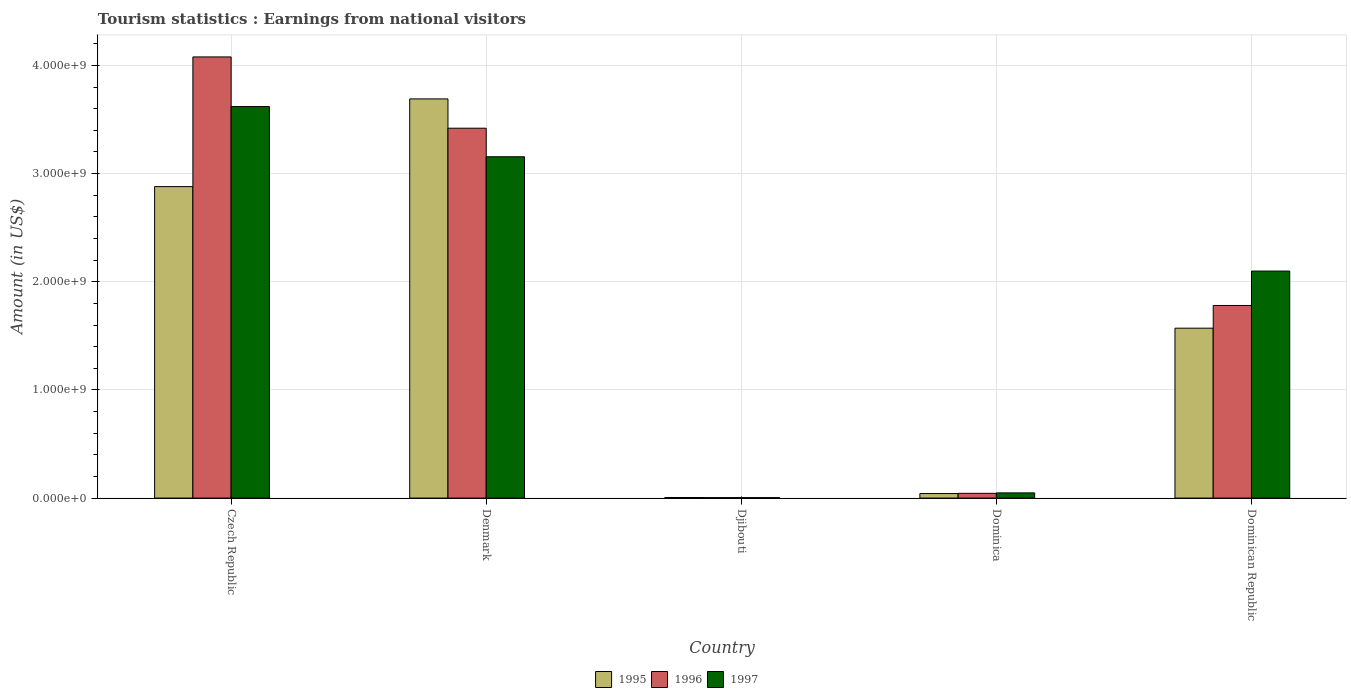How many different coloured bars are there?
Your response must be concise. 3. How many groups of bars are there?
Offer a terse response. 5. Are the number of bars on each tick of the X-axis equal?
Offer a very short reply. Yes. What is the label of the 4th group of bars from the left?
Your answer should be compact. Dominica. In how many cases, is the number of bars for a given country not equal to the number of legend labels?
Provide a succinct answer. 0. What is the earnings from national visitors in 1995 in Czech Republic?
Offer a very short reply. 2.88e+09. Across all countries, what is the maximum earnings from national visitors in 1997?
Offer a very short reply. 3.62e+09. Across all countries, what is the minimum earnings from national visitors in 1995?
Keep it short and to the point. 5.40e+06. In which country was the earnings from national visitors in 1995 maximum?
Provide a succinct answer. Denmark. In which country was the earnings from national visitors in 1996 minimum?
Your response must be concise. Djibouti. What is the total earnings from national visitors in 1997 in the graph?
Make the answer very short. 8.93e+09. What is the difference between the earnings from national visitors in 1997 in Denmark and that in Djibouti?
Offer a very short reply. 3.15e+09. What is the difference between the earnings from national visitors in 1996 in Dominican Republic and the earnings from national visitors in 1997 in Djibouti?
Your answer should be compact. 1.78e+09. What is the average earnings from national visitors in 1995 per country?
Provide a succinct answer. 1.64e+09. What is the difference between the earnings from national visitors of/in 1997 and earnings from national visitors of/in 1996 in Djibouti?
Make the answer very short. -4.00e+05. In how many countries, is the earnings from national visitors in 1995 greater than 400000000 US$?
Provide a short and direct response. 3. What is the ratio of the earnings from national visitors in 1997 in Djibouti to that in Dominica?
Provide a succinct answer. 0.09. What is the difference between the highest and the second highest earnings from national visitors in 1995?
Keep it short and to the point. 8.11e+08. What is the difference between the highest and the lowest earnings from national visitors in 1996?
Your answer should be compact. 4.07e+09. In how many countries, is the earnings from national visitors in 1996 greater than the average earnings from national visitors in 1996 taken over all countries?
Your answer should be compact. 2. What does the 1st bar from the left in Dominican Republic represents?
Give a very brief answer. 1995. What does the 1st bar from the right in Czech Republic represents?
Provide a short and direct response. 1997. How many countries are there in the graph?
Your answer should be compact. 5. What is the difference between two consecutive major ticks on the Y-axis?
Provide a succinct answer. 1.00e+09. Does the graph contain any zero values?
Offer a terse response. No. Does the graph contain grids?
Offer a terse response. Yes. Where does the legend appear in the graph?
Offer a terse response. Bottom center. How many legend labels are there?
Offer a very short reply. 3. What is the title of the graph?
Provide a short and direct response. Tourism statistics : Earnings from national visitors. Does "1965" appear as one of the legend labels in the graph?
Your answer should be compact. No. What is the Amount (in US$) of 1995 in Czech Republic?
Make the answer very short. 2.88e+09. What is the Amount (in US$) of 1996 in Czech Republic?
Your answer should be very brief. 4.08e+09. What is the Amount (in US$) of 1997 in Czech Republic?
Give a very brief answer. 3.62e+09. What is the Amount (in US$) in 1995 in Denmark?
Provide a succinct answer. 3.69e+09. What is the Amount (in US$) of 1996 in Denmark?
Offer a very short reply. 3.42e+09. What is the Amount (in US$) of 1997 in Denmark?
Your answer should be compact. 3.16e+09. What is the Amount (in US$) in 1995 in Djibouti?
Provide a succinct answer. 5.40e+06. What is the Amount (in US$) in 1996 in Djibouti?
Your answer should be compact. 4.60e+06. What is the Amount (in US$) in 1997 in Djibouti?
Offer a terse response. 4.20e+06. What is the Amount (in US$) in 1995 in Dominica?
Make the answer very short. 4.20e+07. What is the Amount (in US$) of 1996 in Dominica?
Your answer should be very brief. 4.40e+07. What is the Amount (in US$) of 1997 in Dominica?
Give a very brief answer. 4.80e+07. What is the Amount (in US$) of 1995 in Dominican Republic?
Ensure brevity in your answer.  1.57e+09. What is the Amount (in US$) of 1996 in Dominican Republic?
Ensure brevity in your answer.  1.78e+09. What is the Amount (in US$) in 1997 in Dominican Republic?
Provide a succinct answer. 2.10e+09. Across all countries, what is the maximum Amount (in US$) in 1995?
Your answer should be compact. 3.69e+09. Across all countries, what is the maximum Amount (in US$) of 1996?
Offer a very short reply. 4.08e+09. Across all countries, what is the maximum Amount (in US$) of 1997?
Make the answer very short. 3.62e+09. Across all countries, what is the minimum Amount (in US$) of 1995?
Your answer should be compact. 5.40e+06. Across all countries, what is the minimum Amount (in US$) of 1996?
Your answer should be compact. 4.60e+06. Across all countries, what is the minimum Amount (in US$) of 1997?
Your answer should be compact. 4.20e+06. What is the total Amount (in US$) in 1995 in the graph?
Provide a short and direct response. 8.19e+09. What is the total Amount (in US$) of 1996 in the graph?
Offer a very short reply. 9.33e+09. What is the total Amount (in US$) in 1997 in the graph?
Make the answer very short. 8.93e+09. What is the difference between the Amount (in US$) in 1995 in Czech Republic and that in Denmark?
Give a very brief answer. -8.11e+08. What is the difference between the Amount (in US$) in 1996 in Czech Republic and that in Denmark?
Offer a very short reply. 6.59e+08. What is the difference between the Amount (in US$) in 1997 in Czech Republic and that in Denmark?
Offer a terse response. 4.64e+08. What is the difference between the Amount (in US$) in 1995 in Czech Republic and that in Djibouti?
Make the answer very short. 2.87e+09. What is the difference between the Amount (in US$) in 1996 in Czech Republic and that in Djibouti?
Your response must be concise. 4.07e+09. What is the difference between the Amount (in US$) of 1997 in Czech Republic and that in Djibouti?
Your answer should be compact. 3.62e+09. What is the difference between the Amount (in US$) in 1995 in Czech Republic and that in Dominica?
Your response must be concise. 2.84e+09. What is the difference between the Amount (in US$) in 1996 in Czech Republic and that in Dominica?
Ensure brevity in your answer.  4.04e+09. What is the difference between the Amount (in US$) of 1997 in Czech Republic and that in Dominica?
Your response must be concise. 3.57e+09. What is the difference between the Amount (in US$) in 1995 in Czech Republic and that in Dominican Republic?
Your response must be concise. 1.31e+09. What is the difference between the Amount (in US$) in 1996 in Czech Republic and that in Dominican Republic?
Make the answer very short. 2.30e+09. What is the difference between the Amount (in US$) in 1997 in Czech Republic and that in Dominican Republic?
Your answer should be compact. 1.52e+09. What is the difference between the Amount (in US$) of 1995 in Denmark and that in Djibouti?
Offer a very short reply. 3.69e+09. What is the difference between the Amount (in US$) of 1996 in Denmark and that in Djibouti?
Your answer should be very brief. 3.42e+09. What is the difference between the Amount (in US$) in 1997 in Denmark and that in Djibouti?
Ensure brevity in your answer.  3.15e+09. What is the difference between the Amount (in US$) of 1995 in Denmark and that in Dominica?
Ensure brevity in your answer.  3.65e+09. What is the difference between the Amount (in US$) of 1996 in Denmark and that in Dominica?
Offer a terse response. 3.38e+09. What is the difference between the Amount (in US$) in 1997 in Denmark and that in Dominica?
Provide a short and direct response. 3.11e+09. What is the difference between the Amount (in US$) in 1995 in Denmark and that in Dominican Republic?
Offer a terse response. 2.12e+09. What is the difference between the Amount (in US$) in 1996 in Denmark and that in Dominican Republic?
Provide a succinct answer. 1.64e+09. What is the difference between the Amount (in US$) of 1997 in Denmark and that in Dominican Republic?
Make the answer very short. 1.06e+09. What is the difference between the Amount (in US$) in 1995 in Djibouti and that in Dominica?
Provide a short and direct response. -3.66e+07. What is the difference between the Amount (in US$) in 1996 in Djibouti and that in Dominica?
Provide a short and direct response. -3.94e+07. What is the difference between the Amount (in US$) in 1997 in Djibouti and that in Dominica?
Make the answer very short. -4.38e+07. What is the difference between the Amount (in US$) of 1995 in Djibouti and that in Dominican Republic?
Offer a terse response. -1.57e+09. What is the difference between the Amount (in US$) in 1996 in Djibouti and that in Dominican Republic?
Ensure brevity in your answer.  -1.78e+09. What is the difference between the Amount (in US$) of 1997 in Djibouti and that in Dominican Republic?
Offer a very short reply. -2.09e+09. What is the difference between the Amount (in US$) in 1995 in Dominica and that in Dominican Republic?
Offer a very short reply. -1.53e+09. What is the difference between the Amount (in US$) in 1996 in Dominica and that in Dominican Republic?
Give a very brief answer. -1.74e+09. What is the difference between the Amount (in US$) of 1997 in Dominica and that in Dominican Republic?
Provide a short and direct response. -2.05e+09. What is the difference between the Amount (in US$) of 1995 in Czech Republic and the Amount (in US$) of 1996 in Denmark?
Ensure brevity in your answer.  -5.40e+08. What is the difference between the Amount (in US$) of 1995 in Czech Republic and the Amount (in US$) of 1997 in Denmark?
Ensure brevity in your answer.  -2.76e+08. What is the difference between the Amount (in US$) of 1996 in Czech Republic and the Amount (in US$) of 1997 in Denmark?
Offer a very short reply. 9.23e+08. What is the difference between the Amount (in US$) in 1995 in Czech Republic and the Amount (in US$) in 1996 in Djibouti?
Your answer should be very brief. 2.88e+09. What is the difference between the Amount (in US$) in 1995 in Czech Republic and the Amount (in US$) in 1997 in Djibouti?
Make the answer very short. 2.88e+09. What is the difference between the Amount (in US$) of 1996 in Czech Republic and the Amount (in US$) of 1997 in Djibouti?
Make the answer very short. 4.07e+09. What is the difference between the Amount (in US$) in 1995 in Czech Republic and the Amount (in US$) in 1996 in Dominica?
Provide a succinct answer. 2.84e+09. What is the difference between the Amount (in US$) of 1995 in Czech Republic and the Amount (in US$) of 1997 in Dominica?
Ensure brevity in your answer.  2.83e+09. What is the difference between the Amount (in US$) in 1996 in Czech Republic and the Amount (in US$) in 1997 in Dominica?
Give a very brief answer. 4.03e+09. What is the difference between the Amount (in US$) of 1995 in Czech Republic and the Amount (in US$) of 1996 in Dominican Republic?
Ensure brevity in your answer.  1.10e+09. What is the difference between the Amount (in US$) in 1995 in Czech Republic and the Amount (in US$) in 1997 in Dominican Republic?
Ensure brevity in your answer.  7.81e+08. What is the difference between the Amount (in US$) in 1996 in Czech Republic and the Amount (in US$) in 1997 in Dominican Republic?
Offer a terse response. 1.98e+09. What is the difference between the Amount (in US$) in 1995 in Denmark and the Amount (in US$) in 1996 in Djibouti?
Offer a terse response. 3.69e+09. What is the difference between the Amount (in US$) in 1995 in Denmark and the Amount (in US$) in 1997 in Djibouti?
Offer a terse response. 3.69e+09. What is the difference between the Amount (in US$) of 1996 in Denmark and the Amount (in US$) of 1997 in Djibouti?
Your answer should be very brief. 3.42e+09. What is the difference between the Amount (in US$) of 1995 in Denmark and the Amount (in US$) of 1996 in Dominica?
Provide a succinct answer. 3.65e+09. What is the difference between the Amount (in US$) of 1995 in Denmark and the Amount (in US$) of 1997 in Dominica?
Keep it short and to the point. 3.64e+09. What is the difference between the Amount (in US$) in 1996 in Denmark and the Amount (in US$) in 1997 in Dominica?
Ensure brevity in your answer.  3.37e+09. What is the difference between the Amount (in US$) of 1995 in Denmark and the Amount (in US$) of 1996 in Dominican Republic?
Offer a very short reply. 1.91e+09. What is the difference between the Amount (in US$) of 1995 in Denmark and the Amount (in US$) of 1997 in Dominican Republic?
Give a very brief answer. 1.59e+09. What is the difference between the Amount (in US$) of 1996 in Denmark and the Amount (in US$) of 1997 in Dominican Republic?
Your answer should be very brief. 1.32e+09. What is the difference between the Amount (in US$) of 1995 in Djibouti and the Amount (in US$) of 1996 in Dominica?
Give a very brief answer. -3.86e+07. What is the difference between the Amount (in US$) of 1995 in Djibouti and the Amount (in US$) of 1997 in Dominica?
Give a very brief answer. -4.26e+07. What is the difference between the Amount (in US$) in 1996 in Djibouti and the Amount (in US$) in 1997 in Dominica?
Make the answer very short. -4.34e+07. What is the difference between the Amount (in US$) of 1995 in Djibouti and the Amount (in US$) of 1996 in Dominican Republic?
Provide a short and direct response. -1.78e+09. What is the difference between the Amount (in US$) in 1995 in Djibouti and the Amount (in US$) in 1997 in Dominican Republic?
Keep it short and to the point. -2.09e+09. What is the difference between the Amount (in US$) of 1996 in Djibouti and the Amount (in US$) of 1997 in Dominican Republic?
Keep it short and to the point. -2.09e+09. What is the difference between the Amount (in US$) in 1995 in Dominica and the Amount (in US$) in 1996 in Dominican Republic?
Give a very brief answer. -1.74e+09. What is the difference between the Amount (in US$) of 1995 in Dominica and the Amount (in US$) of 1997 in Dominican Republic?
Ensure brevity in your answer.  -2.06e+09. What is the difference between the Amount (in US$) of 1996 in Dominica and the Amount (in US$) of 1997 in Dominican Republic?
Make the answer very short. -2.06e+09. What is the average Amount (in US$) of 1995 per country?
Your response must be concise. 1.64e+09. What is the average Amount (in US$) of 1996 per country?
Your answer should be very brief. 1.87e+09. What is the average Amount (in US$) in 1997 per country?
Keep it short and to the point. 1.79e+09. What is the difference between the Amount (in US$) of 1995 and Amount (in US$) of 1996 in Czech Republic?
Your answer should be very brief. -1.20e+09. What is the difference between the Amount (in US$) of 1995 and Amount (in US$) of 1997 in Czech Republic?
Provide a short and direct response. -7.40e+08. What is the difference between the Amount (in US$) of 1996 and Amount (in US$) of 1997 in Czech Republic?
Provide a short and direct response. 4.59e+08. What is the difference between the Amount (in US$) of 1995 and Amount (in US$) of 1996 in Denmark?
Provide a short and direct response. 2.71e+08. What is the difference between the Amount (in US$) of 1995 and Amount (in US$) of 1997 in Denmark?
Your response must be concise. 5.35e+08. What is the difference between the Amount (in US$) in 1996 and Amount (in US$) in 1997 in Denmark?
Give a very brief answer. 2.64e+08. What is the difference between the Amount (in US$) of 1995 and Amount (in US$) of 1996 in Djibouti?
Offer a very short reply. 8.00e+05. What is the difference between the Amount (in US$) in 1995 and Amount (in US$) in 1997 in Djibouti?
Offer a terse response. 1.20e+06. What is the difference between the Amount (in US$) of 1996 and Amount (in US$) of 1997 in Djibouti?
Keep it short and to the point. 4.00e+05. What is the difference between the Amount (in US$) of 1995 and Amount (in US$) of 1996 in Dominica?
Offer a very short reply. -2.00e+06. What is the difference between the Amount (in US$) in 1995 and Amount (in US$) in 1997 in Dominica?
Provide a succinct answer. -6.00e+06. What is the difference between the Amount (in US$) of 1996 and Amount (in US$) of 1997 in Dominica?
Ensure brevity in your answer.  -4.00e+06. What is the difference between the Amount (in US$) of 1995 and Amount (in US$) of 1996 in Dominican Republic?
Give a very brief answer. -2.10e+08. What is the difference between the Amount (in US$) of 1995 and Amount (in US$) of 1997 in Dominican Republic?
Ensure brevity in your answer.  -5.28e+08. What is the difference between the Amount (in US$) in 1996 and Amount (in US$) in 1997 in Dominican Republic?
Your answer should be compact. -3.18e+08. What is the ratio of the Amount (in US$) in 1995 in Czech Republic to that in Denmark?
Your answer should be compact. 0.78. What is the ratio of the Amount (in US$) in 1996 in Czech Republic to that in Denmark?
Your answer should be compact. 1.19. What is the ratio of the Amount (in US$) of 1997 in Czech Republic to that in Denmark?
Offer a terse response. 1.15. What is the ratio of the Amount (in US$) in 1995 in Czech Republic to that in Djibouti?
Ensure brevity in your answer.  533.33. What is the ratio of the Amount (in US$) in 1996 in Czech Republic to that in Djibouti?
Provide a succinct answer. 886.74. What is the ratio of the Amount (in US$) in 1997 in Czech Republic to that in Djibouti?
Your response must be concise. 861.9. What is the ratio of the Amount (in US$) in 1995 in Czech Republic to that in Dominica?
Make the answer very short. 68.57. What is the ratio of the Amount (in US$) of 1996 in Czech Republic to that in Dominica?
Offer a terse response. 92.7. What is the ratio of the Amount (in US$) in 1997 in Czech Republic to that in Dominica?
Ensure brevity in your answer.  75.42. What is the ratio of the Amount (in US$) in 1995 in Czech Republic to that in Dominican Republic?
Your answer should be compact. 1.83. What is the ratio of the Amount (in US$) in 1996 in Czech Republic to that in Dominican Republic?
Provide a short and direct response. 2.29. What is the ratio of the Amount (in US$) in 1997 in Czech Republic to that in Dominican Republic?
Make the answer very short. 1.72. What is the ratio of the Amount (in US$) in 1995 in Denmark to that in Djibouti?
Give a very brief answer. 683.52. What is the ratio of the Amount (in US$) in 1996 in Denmark to that in Djibouti?
Offer a very short reply. 743.48. What is the ratio of the Amount (in US$) of 1997 in Denmark to that in Djibouti?
Your response must be concise. 751.43. What is the ratio of the Amount (in US$) of 1995 in Denmark to that in Dominica?
Provide a short and direct response. 87.88. What is the ratio of the Amount (in US$) of 1996 in Denmark to that in Dominica?
Offer a very short reply. 77.73. What is the ratio of the Amount (in US$) of 1997 in Denmark to that in Dominica?
Provide a succinct answer. 65.75. What is the ratio of the Amount (in US$) of 1995 in Denmark to that in Dominican Republic?
Your answer should be very brief. 2.35. What is the ratio of the Amount (in US$) in 1996 in Denmark to that in Dominican Republic?
Keep it short and to the point. 1.92. What is the ratio of the Amount (in US$) of 1997 in Denmark to that in Dominican Republic?
Make the answer very short. 1.5. What is the ratio of the Amount (in US$) of 1995 in Djibouti to that in Dominica?
Offer a very short reply. 0.13. What is the ratio of the Amount (in US$) of 1996 in Djibouti to that in Dominica?
Your response must be concise. 0.1. What is the ratio of the Amount (in US$) of 1997 in Djibouti to that in Dominica?
Give a very brief answer. 0.09. What is the ratio of the Amount (in US$) of 1995 in Djibouti to that in Dominican Republic?
Give a very brief answer. 0. What is the ratio of the Amount (in US$) in 1996 in Djibouti to that in Dominican Republic?
Provide a succinct answer. 0. What is the ratio of the Amount (in US$) in 1997 in Djibouti to that in Dominican Republic?
Your response must be concise. 0. What is the ratio of the Amount (in US$) in 1995 in Dominica to that in Dominican Republic?
Your answer should be very brief. 0.03. What is the ratio of the Amount (in US$) of 1996 in Dominica to that in Dominican Republic?
Offer a terse response. 0.02. What is the ratio of the Amount (in US$) of 1997 in Dominica to that in Dominican Republic?
Make the answer very short. 0.02. What is the difference between the highest and the second highest Amount (in US$) of 1995?
Make the answer very short. 8.11e+08. What is the difference between the highest and the second highest Amount (in US$) of 1996?
Your response must be concise. 6.59e+08. What is the difference between the highest and the second highest Amount (in US$) in 1997?
Give a very brief answer. 4.64e+08. What is the difference between the highest and the lowest Amount (in US$) of 1995?
Offer a very short reply. 3.69e+09. What is the difference between the highest and the lowest Amount (in US$) in 1996?
Ensure brevity in your answer.  4.07e+09. What is the difference between the highest and the lowest Amount (in US$) in 1997?
Your answer should be very brief. 3.62e+09. 